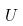Convert formula to latex. <formula><loc_0><loc_0><loc_500><loc_500>U</formula> 